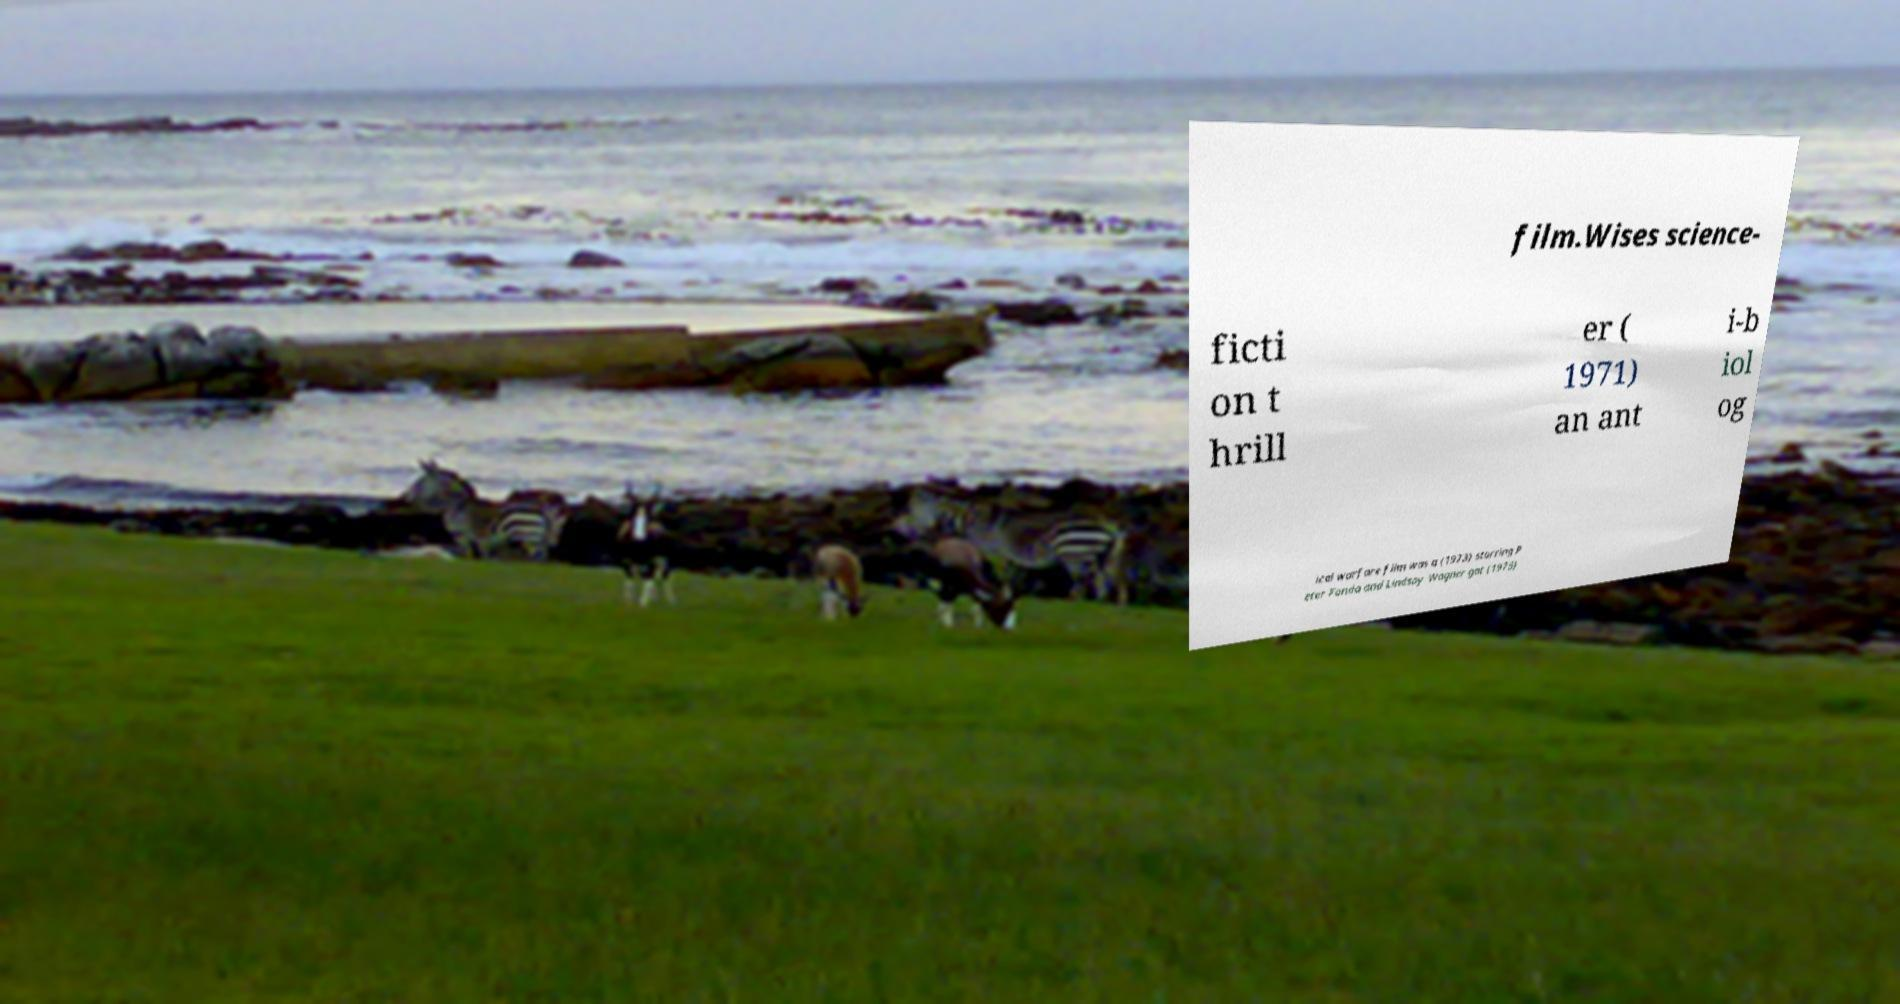Please identify and transcribe the text found in this image. film.Wises science- ficti on t hrill er ( 1971) an ant i-b iol og ical warfare film was a (1973) starring P eter Fonda and Lindsay Wagner got (1975) 